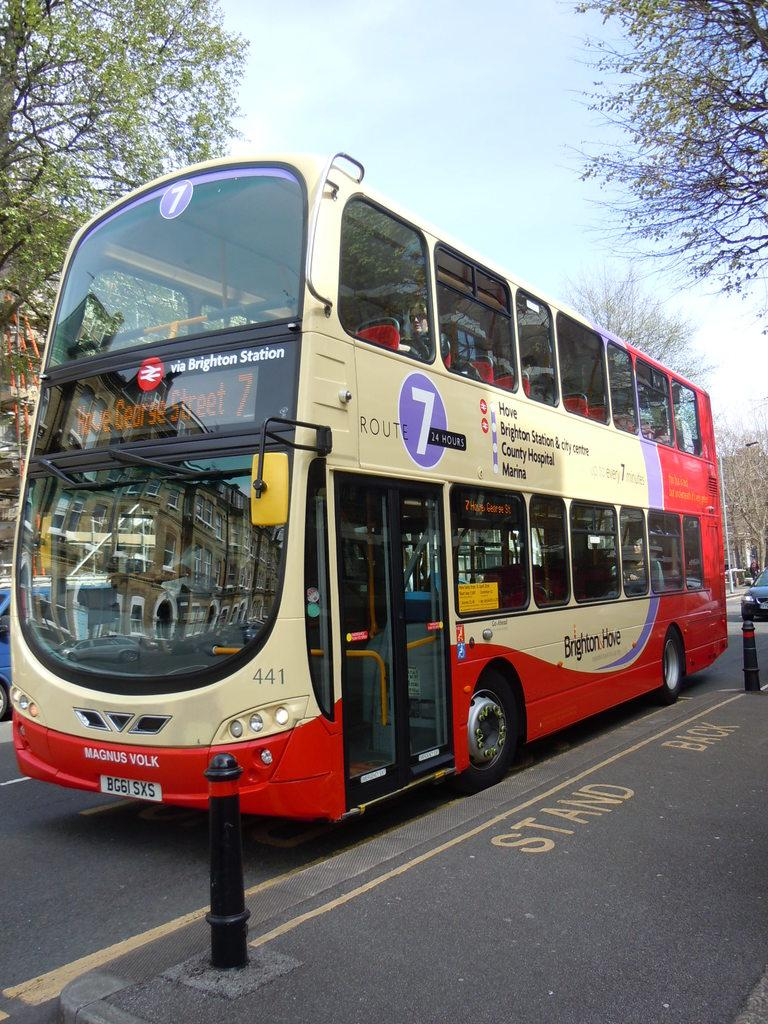What can be seen on the road in the image? There are vehicles on the road in the image. What type of natural scenery is visible in the background of the image? There are trees in the background of the image. What else can be seen in the background of the image? The sky is visible in the background of the image. How many books are stacked on the banana in the image? There is no banana or books present in the image. 